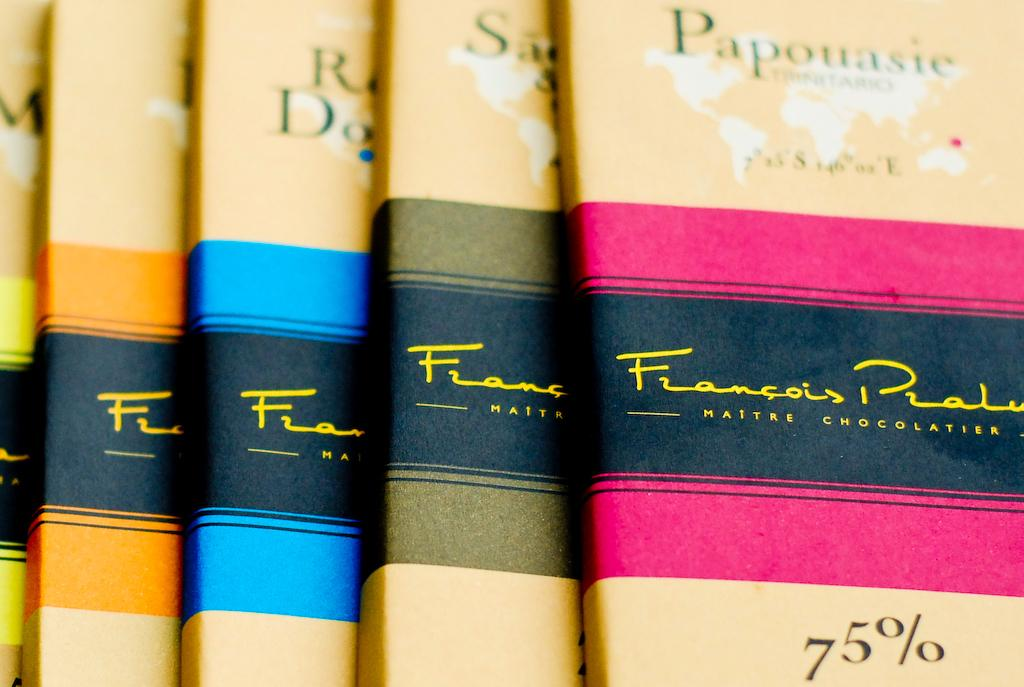Provide a one-sentence caption for the provided image. A row of yellow books by Francois Prate. 